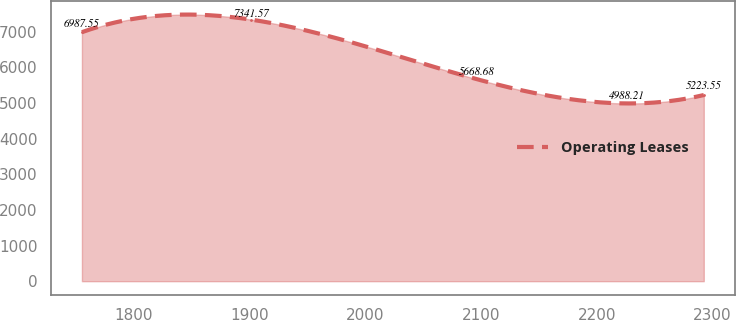Convert chart. <chart><loc_0><loc_0><loc_500><loc_500><line_chart><ecel><fcel>Operating Leases<nl><fcel>1755.6<fcel>6987.55<nl><fcel>1901.33<fcel>7341.57<nl><fcel>2096.6<fcel>5668.68<nl><fcel>2225.75<fcel>4988.21<nl><fcel>2292.46<fcel>5223.55<nl></chart> 